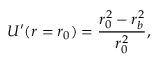Convert formula to latex. <formula><loc_0><loc_0><loc_500><loc_500>U ^ { \prime } ( r = r _ { 0 } ) = \frac { r _ { 0 } ^ { 2 } - r _ { b } ^ { 2 } } { r _ { 0 } ^ { 2 } } ,</formula> 